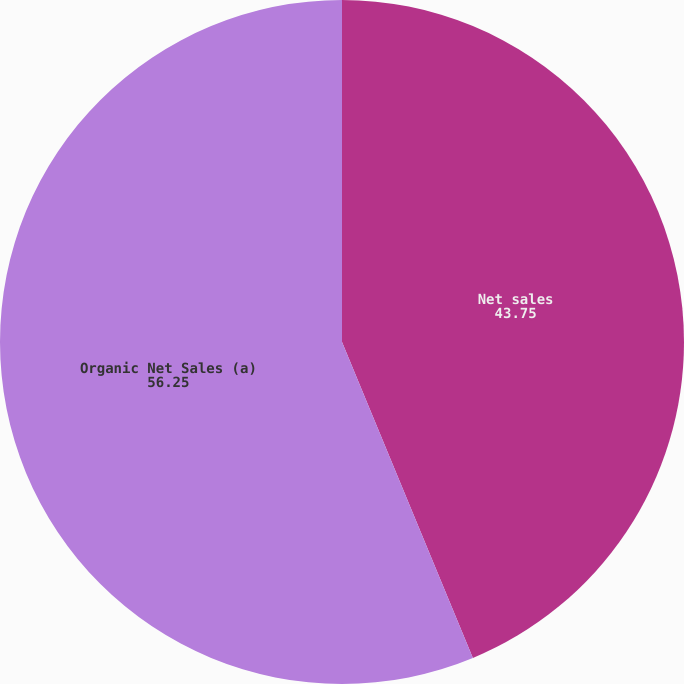Convert chart to OTSL. <chart><loc_0><loc_0><loc_500><loc_500><pie_chart><fcel>Net sales<fcel>Organic Net Sales (a)<nl><fcel>43.75%<fcel>56.25%<nl></chart> 